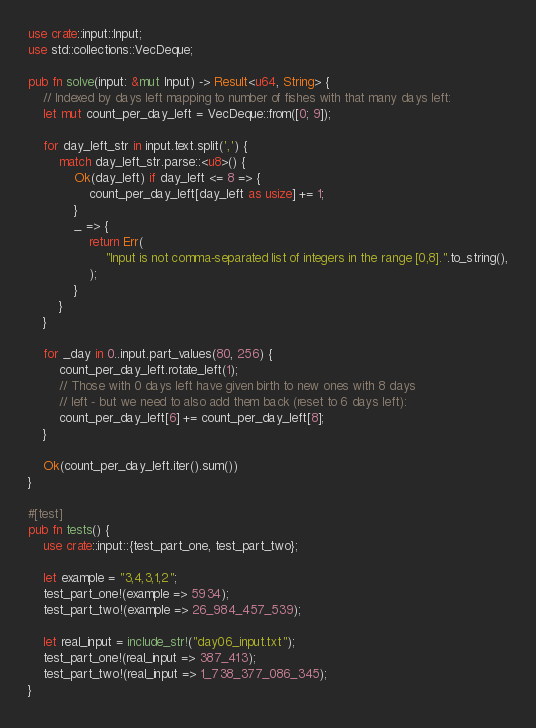Convert code to text. <code><loc_0><loc_0><loc_500><loc_500><_Rust_>use crate::input::Input;
use std::collections::VecDeque;

pub fn solve(input: &mut Input) -> Result<u64, String> {
    // Indexed by days left mapping to number of fishes with that many days left:
    let mut count_per_day_left = VecDeque::from([0; 9]);

    for day_left_str in input.text.split(',') {
        match day_left_str.parse::<u8>() {
            Ok(day_left) if day_left <= 8 => {
                count_per_day_left[day_left as usize] += 1;
            }
            _ => {
                return Err(
                    "Input is not comma-separated list of integers in the range [0,8].".to_string(),
                );
            }
        }
    }

    for _day in 0..input.part_values(80, 256) {
        count_per_day_left.rotate_left(1);
        // Those with 0 days left have given birth to new ones with 8 days
        // left - but we need to also add them back (reset to 6 days left):
        count_per_day_left[6] += count_per_day_left[8];
    }

    Ok(count_per_day_left.iter().sum())
}

#[test]
pub fn tests() {
    use crate::input::{test_part_one, test_part_two};

    let example = "3,4,3,1,2";
    test_part_one!(example => 5934);
    test_part_two!(example => 26_984_457_539);

    let real_input = include_str!("day06_input.txt");
    test_part_one!(real_input => 387_413);
    test_part_two!(real_input => 1_738_377_086_345);
}
</code> 